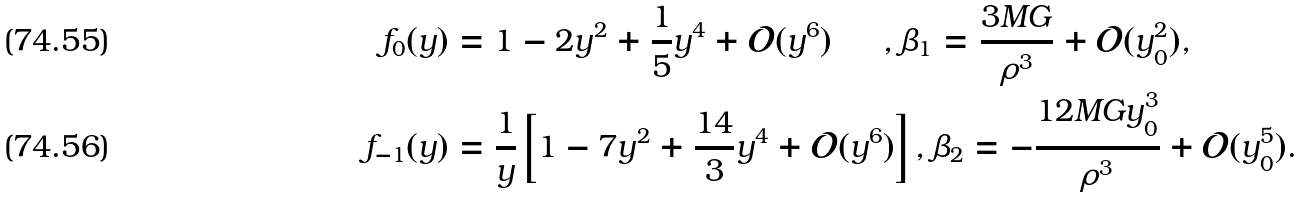Convert formula to latex. <formula><loc_0><loc_0><loc_500><loc_500>f _ { 0 } ( y ) & = 1 - 2 y ^ { 2 } + \frac { 1 } { 5 } y ^ { 4 } + \mathcal { O } ( y ^ { 6 } ) \quad \ \ , \beta _ { 1 } = \frac { 3 M G } { \rho ^ { 3 } } + \mathcal { O } ( y _ { 0 } ^ { 2 } ) , \\ f _ { - 1 } ( y ) & = \frac { 1 } { y } \left [ 1 - 7 y ^ { 2 } + \frac { 1 4 } { 3 } y ^ { 4 } + \mathcal { O } ( y ^ { 6 } ) \right ] , \beta _ { 2 } = - \frac { 1 2 M G y _ { 0 } ^ { 3 } } { \rho ^ { 3 } } + \mathcal { O } ( y _ { 0 } ^ { 5 } ) .</formula> 